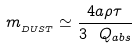Convert formula to latex. <formula><loc_0><loc_0><loc_500><loc_500>m _ { _ { D U S T } } \simeq \frac { 4 a \rho \tau } { 3 \ Q _ { a b s } }</formula> 